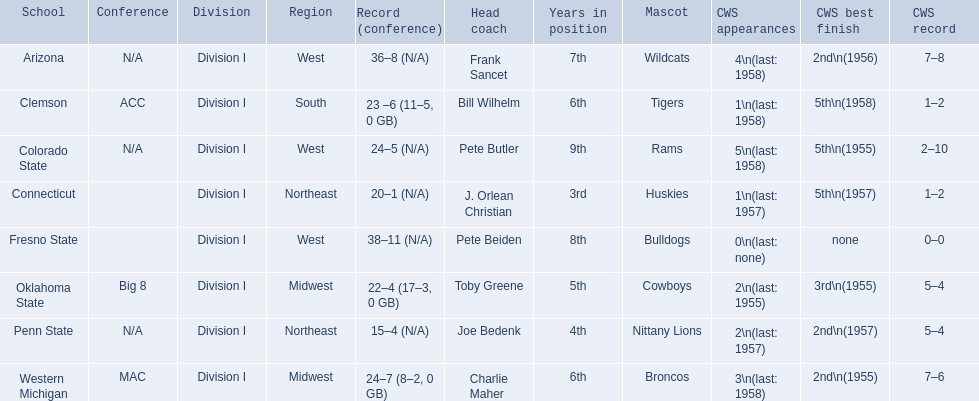Which teams played in the 1959 ncaa university division baseball tournament? Arizona, Clemson, Colorado State, Connecticut, Fresno State, Oklahoma State, Penn State, Western Michigan. Which was the only one to win less than 20 games? Penn State. 